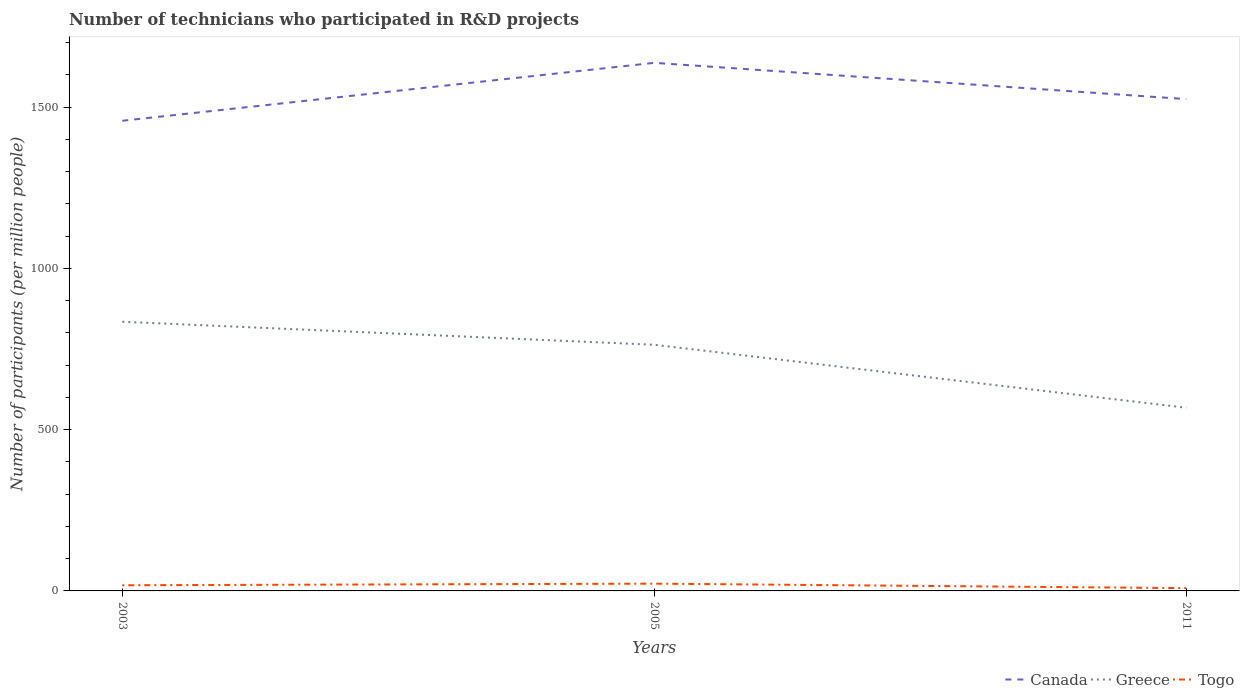How many different coloured lines are there?
Your answer should be compact. 3. Across all years, what is the maximum number of technicians who participated in R&D projects in Togo?
Offer a terse response. 8.62. In which year was the number of technicians who participated in R&D projects in Canada maximum?
Offer a terse response. 2003. What is the total number of technicians who participated in R&D projects in Canada in the graph?
Provide a succinct answer. -179.59. What is the difference between the highest and the second highest number of technicians who participated in R&D projects in Greece?
Your response must be concise. 266.64. What is the difference between the highest and the lowest number of technicians who participated in R&D projects in Canada?
Offer a very short reply. 1. Is the number of technicians who participated in R&D projects in Greece strictly greater than the number of technicians who participated in R&D projects in Togo over the years?
Your answer should be very brief. No. How many lines are there?
Your response must be concise. 3. What is the difference between two consecutive major ticks on the Y-axis?
Your response must be concise. 500. Are the values on the major ticks of Y-axis written in scientific E-notation?
Your response must be concise. No. What is the title of the graph?
Your answer should be compact. Number of technicians who participated in R&D projects. What is the label or title of the X-axis?
Ensure brevity in your answer.  Years. What is the label or title of the Y-axis?
Offer a terse response. Number of participants (per million people). What is the Number of participants (per million people) in Canada in 2003?
Offer a terse response. 1458.07. What is the Number of participants (per million people) in Greece in 2003?
Offer a terse response. 834.74. What is the Number of participants (per million people) of Togo in 2003?
Keep it short and to the point. 17.6. What is the Number of participants (per million people) of Canada in 2005?
Ensure brevity in your answer.  1637.66. What is the Number of participants (per million people) of Greece in 2005?
Provide a short and direct response. 763.38. What is the Number of participants (per million people) of Togo in 2005?
Your answer should be very brief. 22.59. What is the Number of participants (per million people) of Canada in 2011?
Give a very brief answer. 1525.22. What is the Number of participants (per million people) of Greece in 2011?
Offer a very short reply. 568.1. What is the Number of participants (per million people) in Togo in 2011?
Make the answer very short. 8.62. Across all years, what is the maximum Number of participants (per million people) in Canada?
Keep it short and to the point. 1637.66. Across all years, what is the maximum Number of participants (per million people) of Greece?
Your response must be concise. 834.74. Across all years, what is the maximum Number of participants (per million people) in Togo?
Provide a short and direct response. 22.59. Across all years, what is the minimum Number of participants (per million people) in Canada?
Give a very brief answer. 1458.07. Across all years, what is the minimum Number of participants (per million people) of Greece?
Provide a short and direct response. 568.1. Across all years, what is the minimum Number of participants (per million people) of Togo?
Your answer should be very brief. 8.62. What is the total Number of participants (per million people) in Canada in the graph?
Offer a terse response. 4620.95. What is the total Number of participants (per million people) of Greece in the graph?
Provide a short and direct response. 2166.22. What is the total Number of participants (per million people) of Togo in the graph?
Offer a very short reply. 48.81. What is the difference between the Number of participants (per million people) of Canada in 2003 and that in 2005?
Your answer should be very brief. -179.59. What is the difference between the Number of participants (per million people) in Greece in 2003 and that in 2005?
Keep it short and to the point. 71.35. What is the difference between the Number of participants (per million people) in Togo in 2003 and that in 2005?
Keep it short and to the point. -4.99. What is the difference between the Number of participants (per million people) of Canada in 2003 and that in 2011?
Provide a succinct answer. -67.15. What is the difference between the Number of participants (per million people) in Greece in 2003 and that in 2011?
Your answer should be very brief. 266.64. What is the difference between the Number of participants (per million people) in Togo in 2003 and that in 2011?
Offer a very short reply. 8.98. What is the difference between the Number of participants (per million people) of Canada in 2005 and that in 2011?
Ensure brevity in your answer.  112.44. What is the difference between the Number of participants (per million people) of Greece in 2005 and that in 2011?
Provide a short and direct response. 195.28. What is the difference between the Number of participants (per million people) of Togo in 2005 and that in 2011?
Offer a terse response. 13.97. What is the difference between the Number of participants (per million people) in Canada in 2003 and the Number of participants (per million people) in Greece in 2005?
Ensure brevity in your answer.  694.69. What is the difference between the Number of participants (per million people) in Canada in 2003 and the Number of participants (per million people) in Togo in 2005?
Make the answer very short. 1435.48. What is the difference between the Number of participants (per million people) of Greece in 2003 and the Number of participants (per million people) of Togo in 2005?
Give a very brief answer. 812.15. What is the difference between the Number of participants (per million people) in Canada in 2003 and the Number of participants (per million people) in Greece in 2011?
Give a very brief answer. 889.97. What is the difference between the Number of participants (per million people) of Canada in 2003 and the Number of participants (per million people) of Togo in 2011?
Keep it short and to the point. 1449.45. What is the difference between the Number of participants (per million people) of Greece in 2003 and the Number of participants (per million people) of Togo in 2011?
Offer a very short reply. 826.12. What is the difference between the Number of participants (per million people) of Canada in 2005 and the Number of participants (per million people) of Greece in 2011?
Provide a short and direct response. 1069.56. What is the difference between the Number of participants (per million people) of Canada in 2005 and the Number of participants (per million people) of Togo in 2011?
Make the answer very short. 1629.04. What is the difference between the Number of participants (per million people) in Greece in 2005 and the Number of participants (per million people) in Togo in 2011?
Provide a short and direct response. 754.76. What is the average Number of participants (per million people) in Canada per year?
Make the answer very short. 1540.32. What is the average Number of participants (per million people) in Greece per year?
Provide a succinct answer. 722.07. What is the average Number of participants (per million people) in Togo per year?
Give a very brief answer. 16.27. In the year 2003, what is the difference between the Number of participants (per million people) in Canada and Number of participants (per million people) in Greece?
Your answer should be very brief. 623.33. In the year 2003, what is the difference between the Number of participants (per million people) in Canada and Number of participants (per million people) in Togo?
Provide a short and direct response. 1440.47. In the year 2003, what is the difference between the Number of participants (per million people) in Greece and Number of participants (per million people) in Togo?
Provide a succinct answer. 817.13. In the year 2005, what is the difference between the Number of participants (per million people) of Canada and Number of participants (per million people) of Greece?
Offer a terse response. 874.28. In the year 2005, what is the difference between the Number of participants (per million people) of Canada and Number of participants (per million people) of Togo?
Provide a short and direct response. 1615.08. In the year 2005, what is the difference between the Number of participants (per million people) of Greece and Number of participants (per million people) of Togo?
Give a very brief answer. 740.8. In the year 2011, what is the difference between the Number of participants (per million people) of Canada and Number of participants (per million people) of Greece?
Offer a terse response. 957.12. In the year 2011, what is the difference between the Number of participants (per million people) in Canada and Number of participants (per million people) in Togo?
Offer a terse response. 1516.6. In the year 2011, what is the difference between the Number of participants (per million people) of Greece and Number of participants (per million people) of Togo?
Keep it short and to the point. 559.48. What is the ratio of the Number of participants (per million people) of Canada in 2003 to that in 2005?
Keep it short and to the point. 0.89. What is the ratio of the Number of participants (per million people) in Greece in 2003 to that in 2005?
Your response must be concise. 1.09. What is the ratio of the Number of participants (per million people) of Togo in 2003 to that in 2005?
Make the answer very short. 0.78. What is the ratio of the Number of participants (per million people) of Canada in 2003 to that in 2011?
Your answer should be compact. 0.96. What is the ratio of the Number of participants (per million people) in Greece in 2003 to that in 2011?
Your answer should be compact. 1.47. What is the ratio of the Number of participants (per million people) in Togo in 2003 to that in 2011?
Give a very brief answer. 2.04. What is the ratio of the Number of participants (per million people) in Canada in 2005 to that in 2011?
Your answer should be very brief. 1.07. What is the ratio of the Number of participants (per million people) in Greece in 2005 to that in 2011?
Make the answer very short. 1.34. What is the ratio of the Number of participants (per million people) of Togo in 2005 to that in 2011?
Provide a succinct answer. 2.62. What is the difference between the highest and the second highest Number of participants (per million people) of Canada?
Give a very brief answer. 112.44. What is the difference between the highest and the second highest Number of participants (per million people) in Greece?
Provide a short and direct response. 71.35. What is the difference between the highest and the second highest Number of participants (per million people) of Togo?
Give a very brief answer. 4.99. What is the difference between the highest and the lowest Number of participants (per million people) of Canada?
Your answer should be very brief. 179.59. What is the difference between the highest and the lowest Number of participants (per million people) of Greece?
Offer a terse response. 266.64. What is the difference between the highest and the lowest Number of participants (per million people) in Togo?
Give a very brief answer. 13.97. 